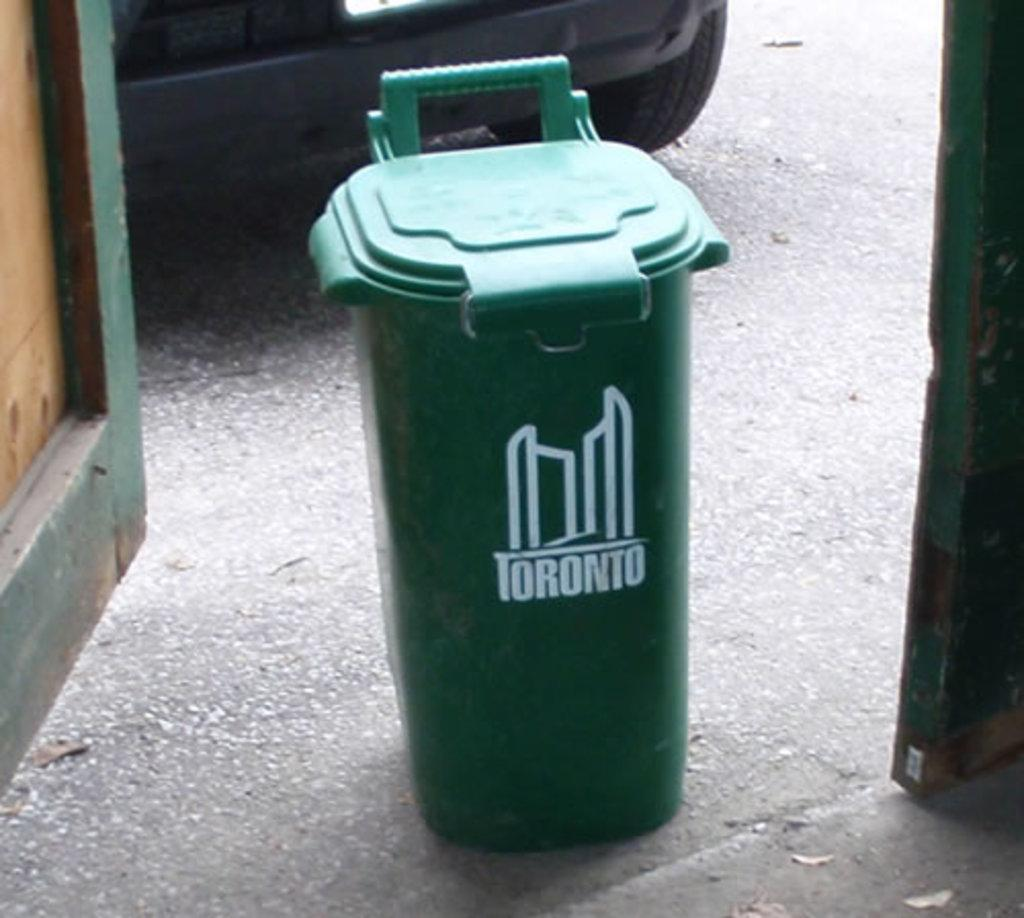<image>
Describe the image concisely. A green trash can that says Toronto on it. 